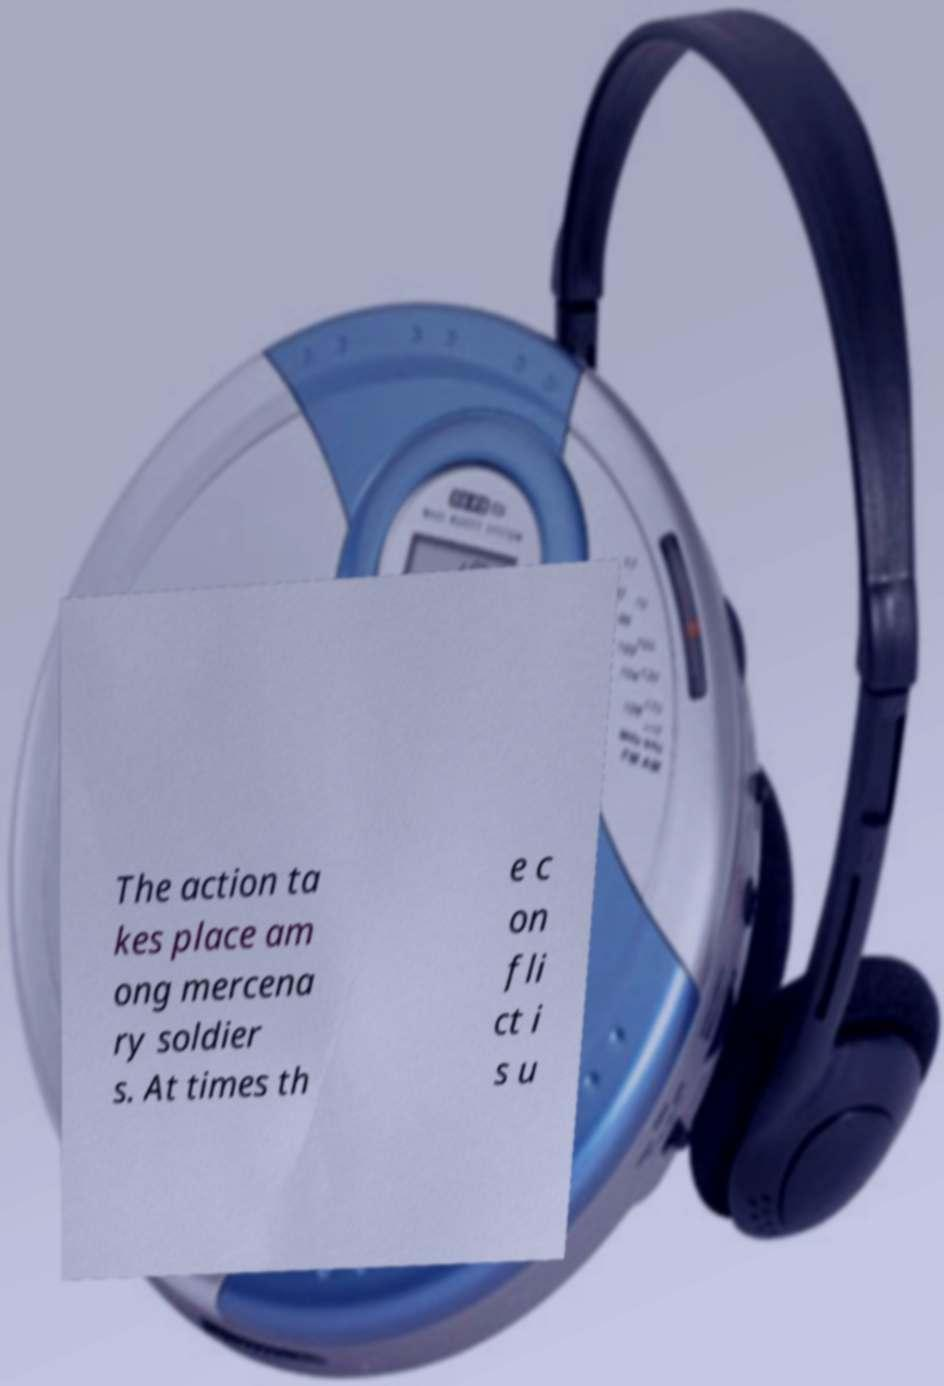Please identify and transcribe the text found in this image. The action ta kes place am ong mercena ry soldier s. At times th e c on fli ct i s u 